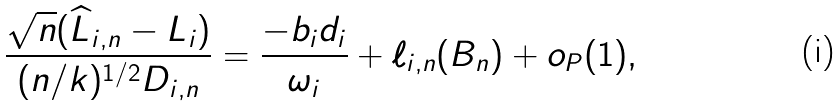<formula> <loc_0><loc_0><loc_500><loc_500>\frac { \sqrt { n } ( \widehat { L } _ { i , n } - L _ { i } ) } { ( n / k ) ^ { 1 / 2 } D _ { i , n } } = { \frac { - b _ { i } d _ { i } } { \omega _ { i } } } + \ell _ { i , n } ( B _ { n } ) + o _ { P } ( 1 ) ,</formula> 